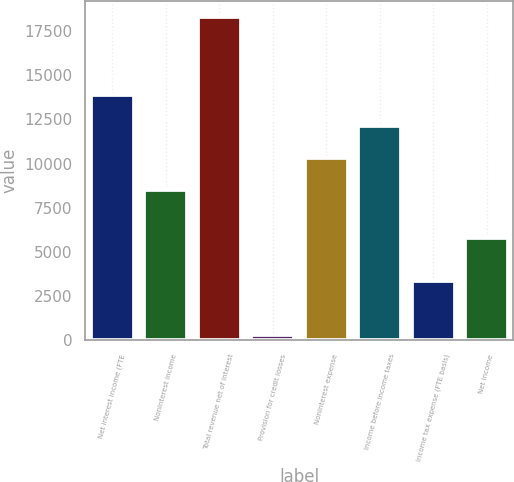Convert chart. <chart><loc_0><loc_0><loc_500><loc_500><bar_chart><fcel>Net interest income (FTE<fcel>Noninterest income<fcel>Total revenue net of interest<fcel>Provision for credit losses<fcel>Noninterest expense<fcel>Income before income taxes<fcel>Income tax expense (FTE basis)<fcel>Net income<nl><fcel>13896.3<fcel>8514<fcel>18266<fcel>325<fcel>10308.1<fcel>12102.2<fcel>3353<fcel>5782<nl></chart> 